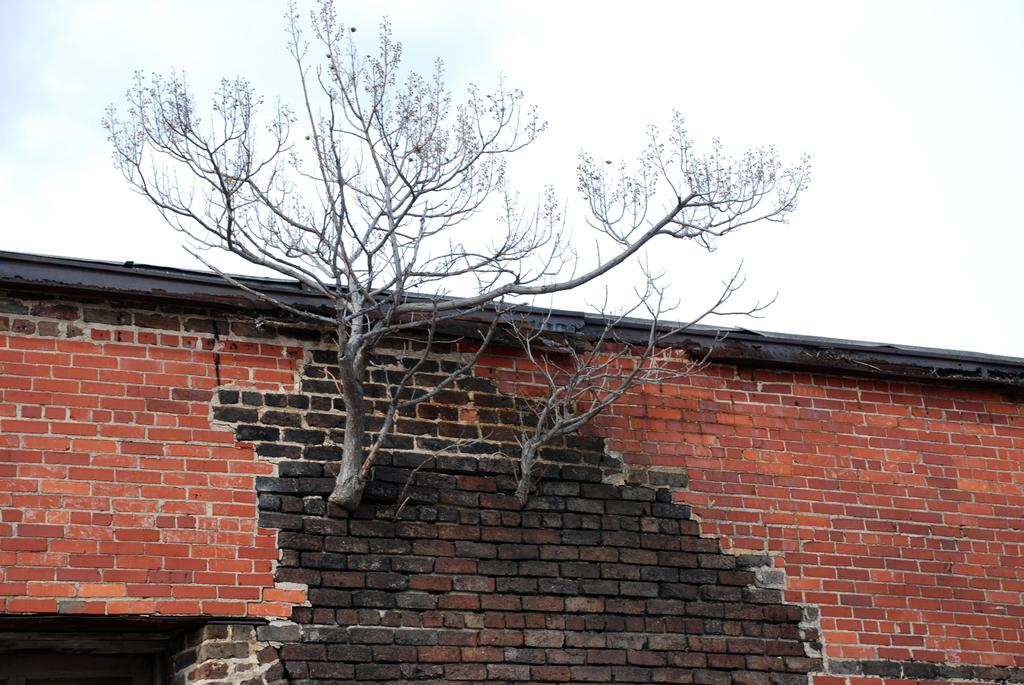What type of vegetation can be seen in the image? There are trees in the image. What structure is present in the image? There is a wall in the image. What can be seen in the background of the image? The sky is visible in the background of the image. What type of beef is being prepared on the wall in the image? There is no beef or any cooking activity present in the image. Can you tell me how many uncles are visible in the image? There are no people, including uncles, present in the image. 